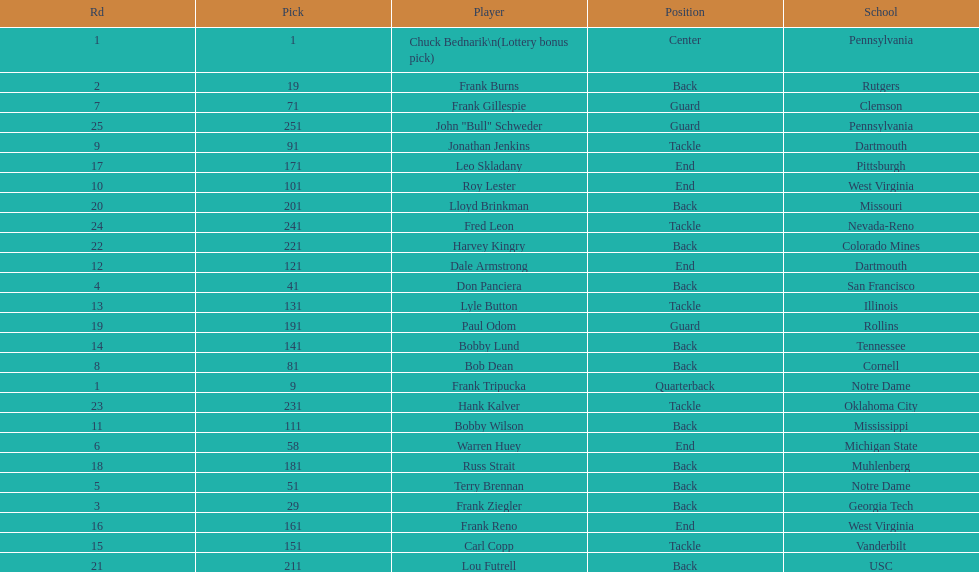Who was the player that the team drafted after bob dean? Jonathan Jenkins. 